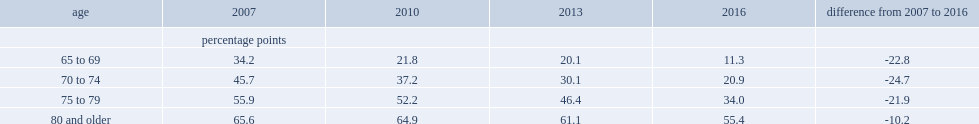How many percentage points did the gap in internet use between the middle-aged and those aged 65 to 69 decline from 2007 to 2016? 22.8. How many percentage points did the gap between the middle-aged and seniors aged 80 and older decline from 2007 to 2016? 10.2. How many percentage points did the gap in internet use between in the middle-aged population and seniors aged 70 to 74 decline from 2007 to 2016? 24.7. How many percentage points did the gap in internet use between in the middle-aged population and seniors aged 75 to 79 decline from 2007 to 2016? 21.9. 